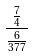<formula> <loc_0><loc_0><loc_500><loc_500>\frac { \frac { 7 } { 4 } } { \frac { 6 } { 3 7 7 } }</formula> 